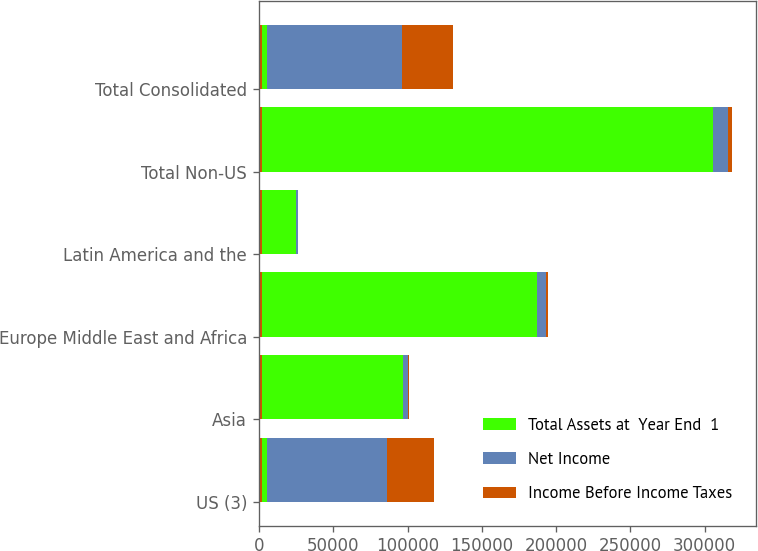<chart> <loc_0><loc_0><loc_500><loc_500><stacked_bar_chart><ecel><fcel>US (3)<fcel>Asia<fcel>Europe Middle East and Africa<fcel>Latin America and the<fcel>Total Non-US<fcel>Total Consolidated<nl><fcel>nan<fcel>2018<fcel>2018<fcel>2018<fcel>2018<fcel>2018<fcel>2018<nl><fcel>Total Assets at  Year End  1<fcel>3093.5<fcel>94865<fcel>185285<fcel>23175<fcel>303325<fcel>3093.5<nl><fcel>Net Income<fcel>81004<fcel>3507<fcel>5632<fcel>1104<fcel>10243<fcel>91247<nl><fcel>Income Before Income Taxes<fcel>31904<fcel>865<fcel>1543<fcel>272<fcel>2680<fcel>34584<nl></chart> 